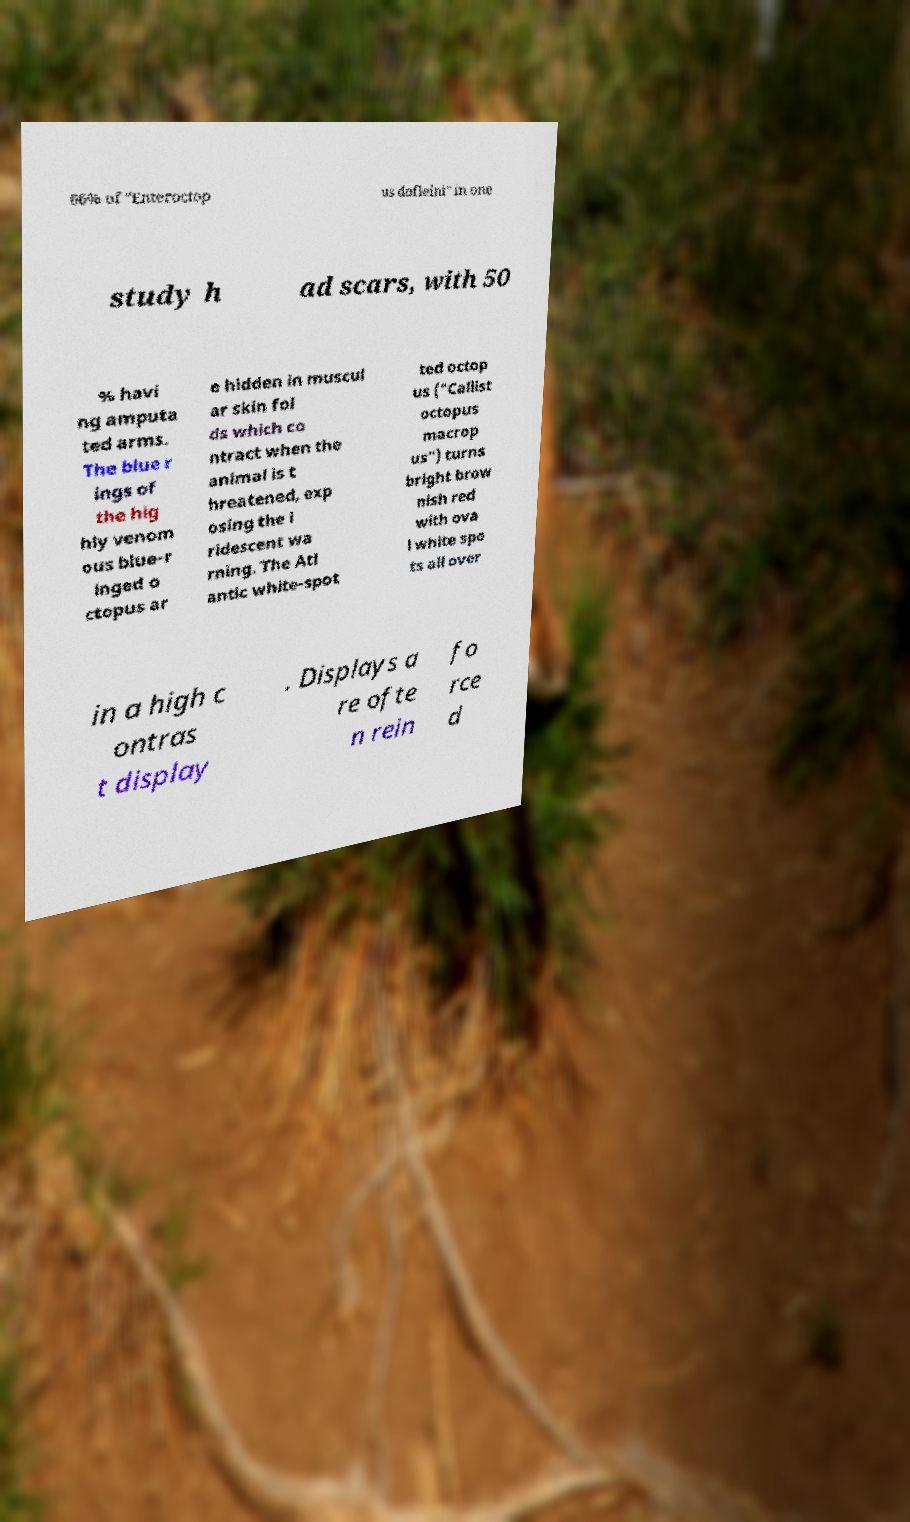Please read and relay the text visible in this image. What does it say? 66% of "Enteroctop us dofleini" in one study h ad scars, with 50 % havi ng amputa ted arms. The blue r ings of the hig hly venom ous blue-r inged o ctopus ar e hidden in muscul ar skin fol ds which co ntract when the animal is t hreatened, exp osing the i ridescent wa rning. The Atl antic white-spot ted octop us ("Callist octopus macrop us") turns bright brow nish red with ova l white spo ts all over in a high c ontras t display . Displays a re ofte n rein fo rce d 